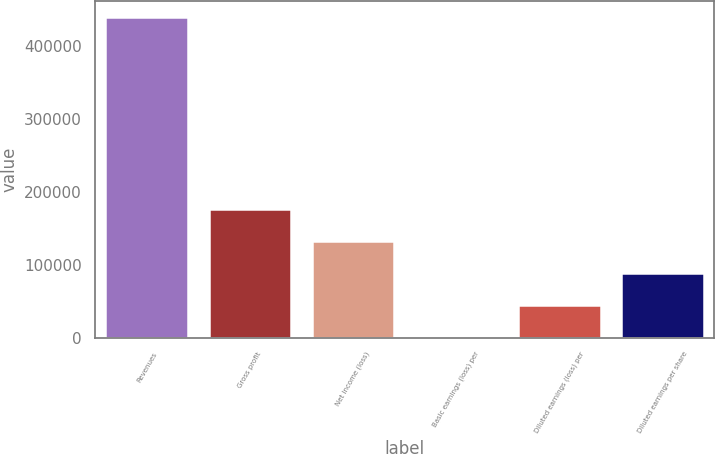Convert chart. <chart><loc_0><loc_0><loc_500><loc_500><bar_chart><fcel>Revenues<fcel>Gross profit<fcel>Net income (loss)<fcel>Basic earnings (loss) per<fcel>Diluted earnings (loss) per<fcel>Diluted earnings per share<nl><fcel>439287<fcel>175715<fcel>131786<fcel>0.03<fcel>43928.7<fcel>87857.4<nl></chart> 